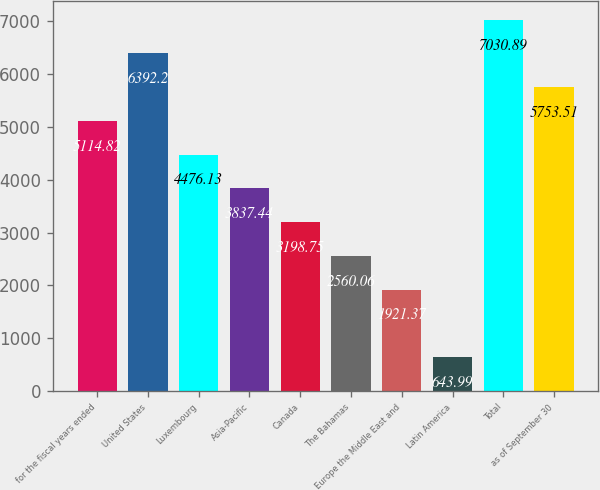Convert chart to OTSL. <chart><loc_0><loc_0><loc_500><loc_500><bar_chart><fcel>for the fiscal years ended<fcel>United States<fcel>Luxembourg<fcel>Asia-Pacific<fcel>Canada<fcel>The Bahamas<fcel>Europe the Middle East and<fcel>Latin America<fcel>Total<fcel>as of September 30<nl><fcel>5114.82<fcel>6392.2<fcel>4476.13<fcel>3837.44<fcel>3198.75<fcel>2560.06<fcel>1921.37<fcel>643.99<fcel>7030.89<fcel>5753.51<nl></chart> 